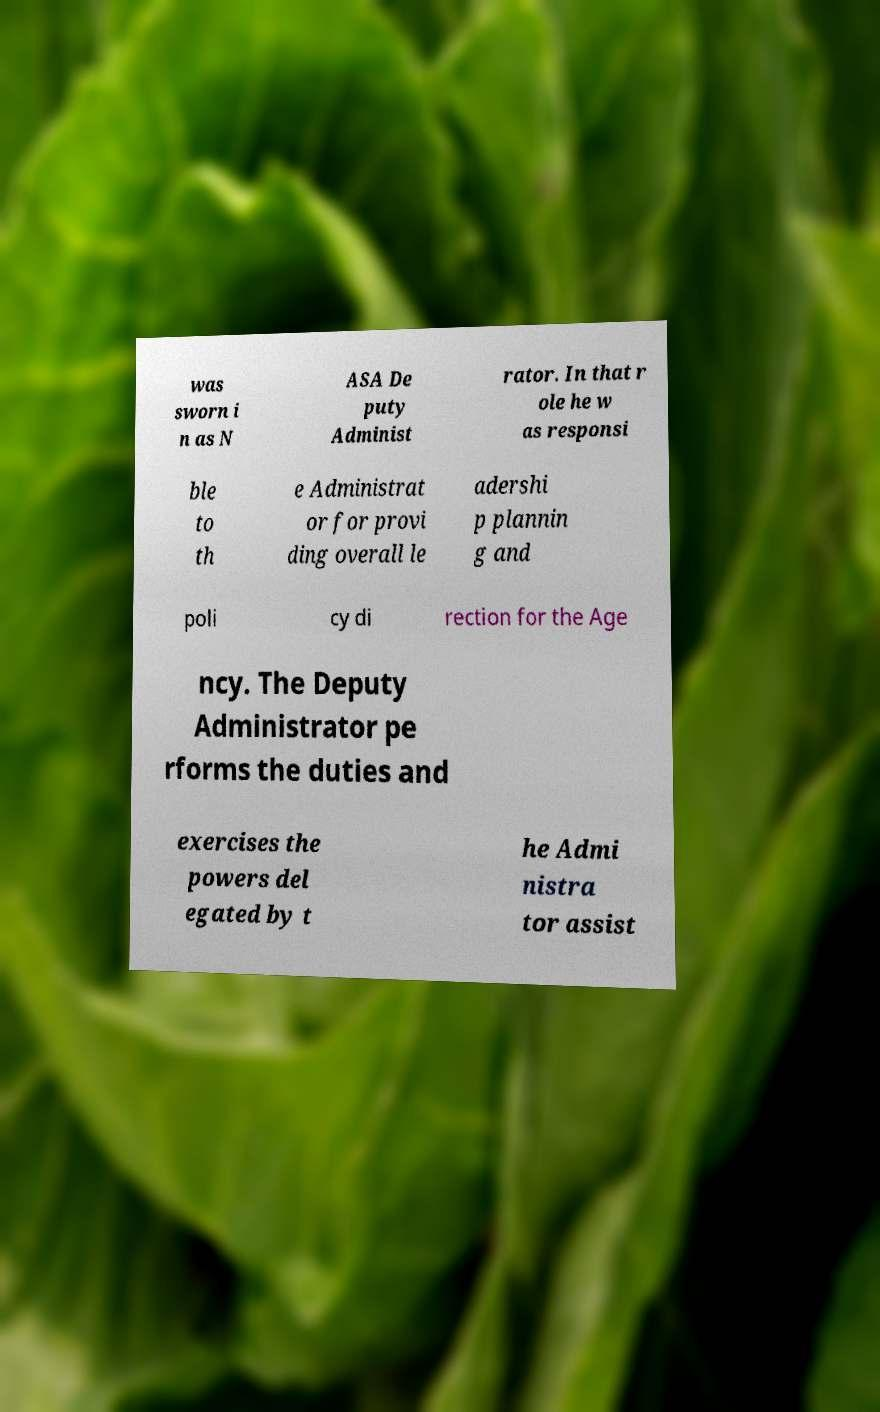Could you extract and type out the text from this image? was sworn i n as N ASA De puty Administ rator. In that r ole he w as responsi ble to th e Administrat or for provi ding overall le adershi p plannin g and poli cy di rection for the Age ncy. The Deputy Administrator pe rforms the duties and exercises the powers del egated by t he Admi nistra tor assist 